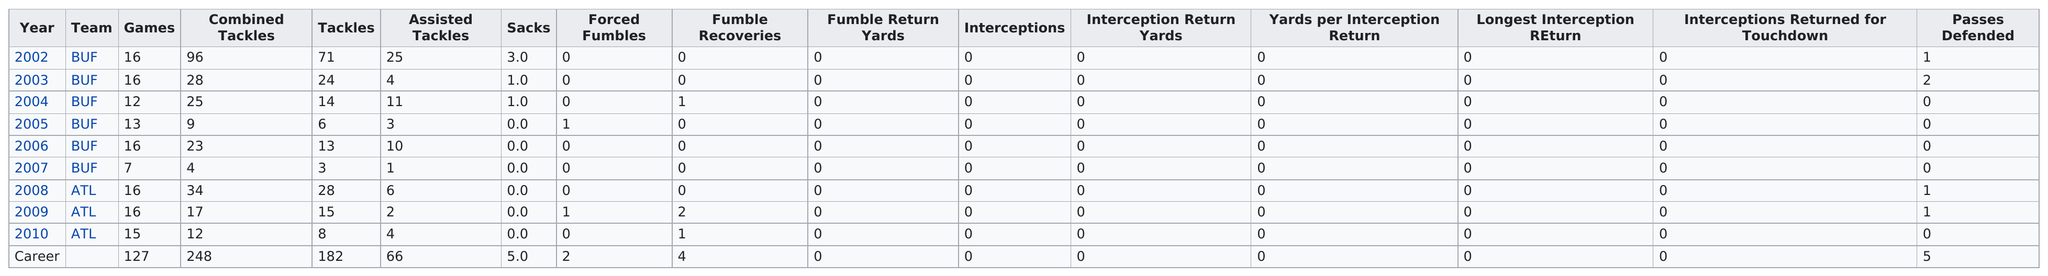Draw attention to some important aspects in this diagram. For which team did this player have the least amount of games played? It was the Buffalo Sabres. In the year 2002, Coy had the most combined tackles. Coy played for the Atlanta Falcons after he played for the Buffalo Bills. The total number of passes this player has defended is 5. In one year, the Buffalo Sabres played only seven games, which is the fewest number of games that the team has ever played in a season. 